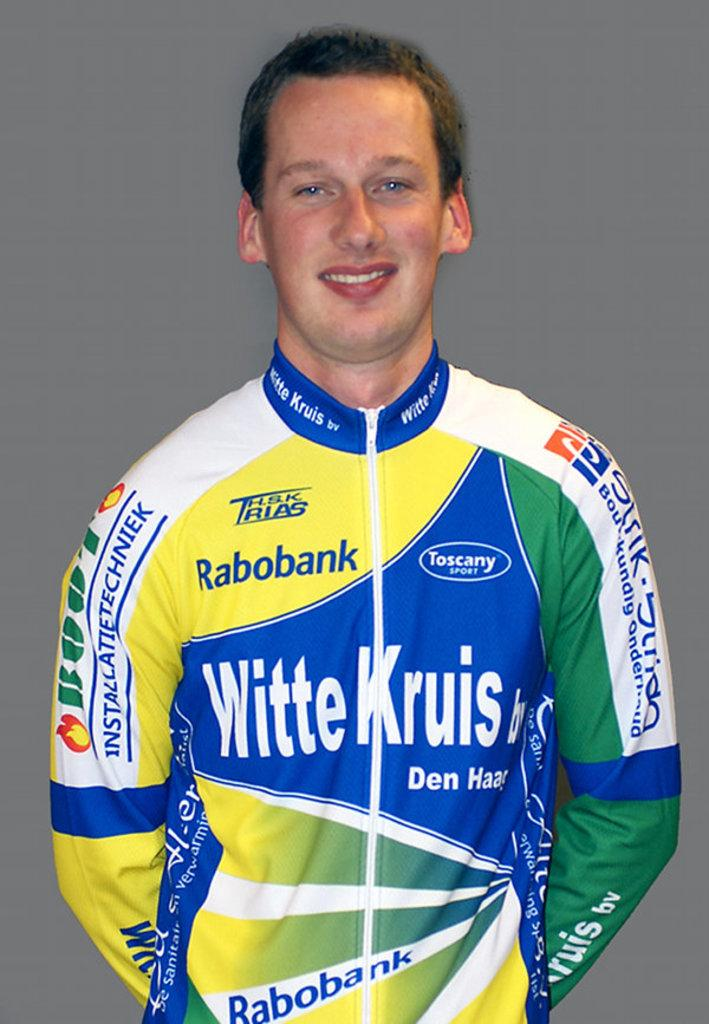<image>
Offer a succinct explanation of the picture presented. A guy wears a jacket with logos on it including Rabobank. 